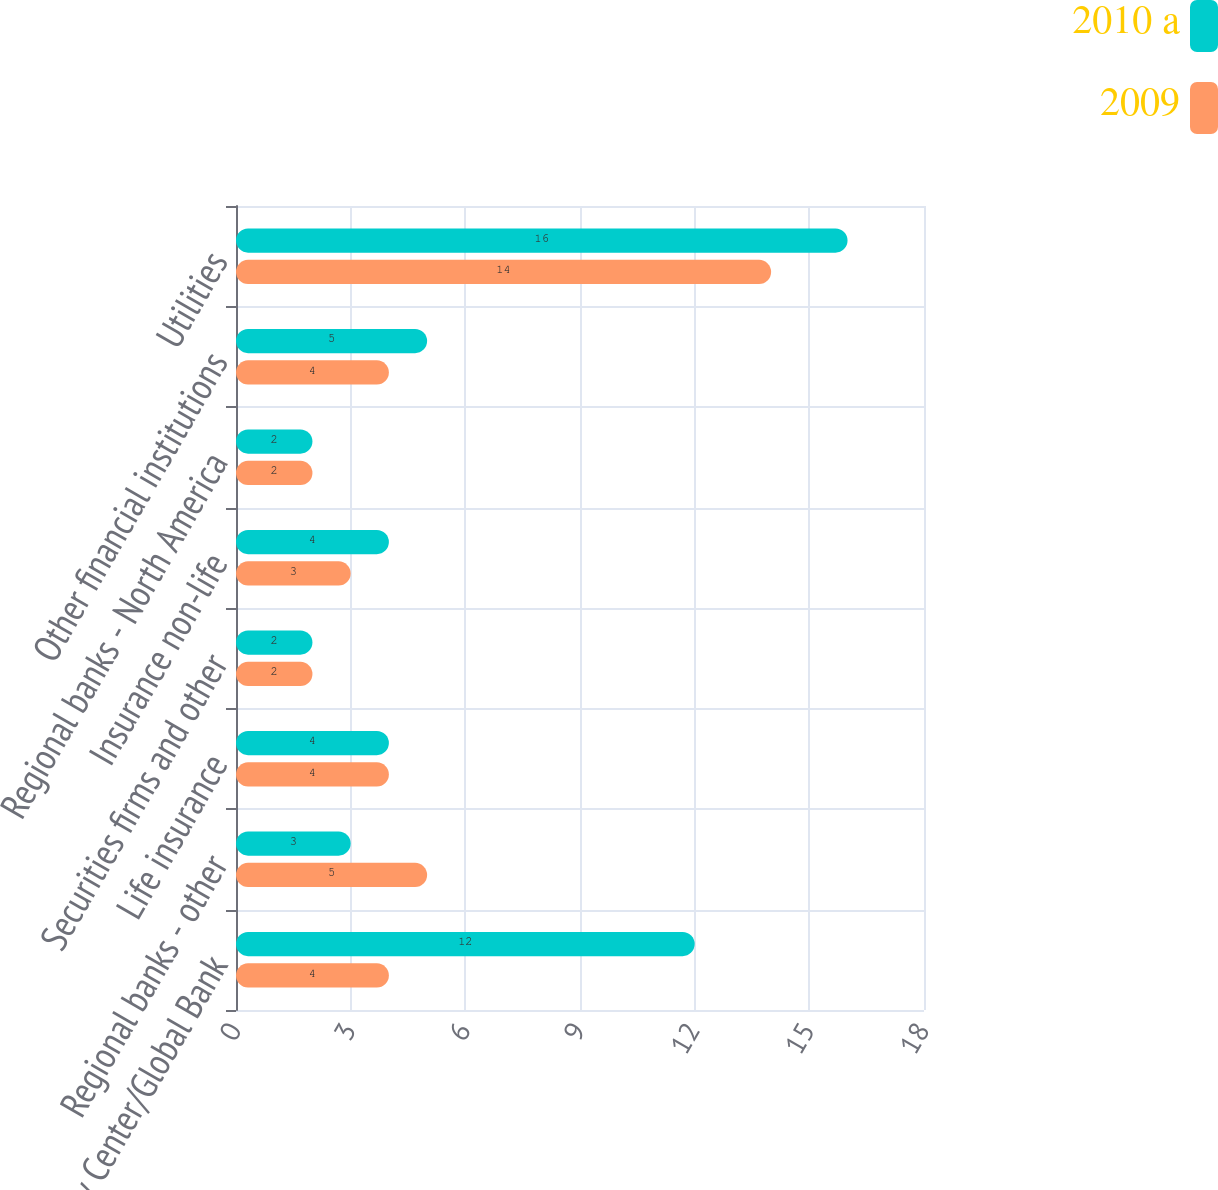Convert chart. <chart><loc_0><loc_0><loc_500><loc_500><stacked_bar_chart><ecel><fcel>Money Center/Global Bank<fcel>Regional banks - other<fcel>Life insurance<fcel>Securities firms and other<fcel>Insurance non-life<fcel>Regional banks - North America<fcel>Other financial institutions<fcel>Utilities<nl><fcel>2010 a<fcel>12<fcel>3<fcel>4<fcel>2<fcel>4<fcel>2<fcel>5<fcel>16<nl><fcel>2009<fcel>4<fcel>5<fcel>4<fcel>2<fcel>3<fcel>2<fcel>4<fcel>14<nl></chart> 